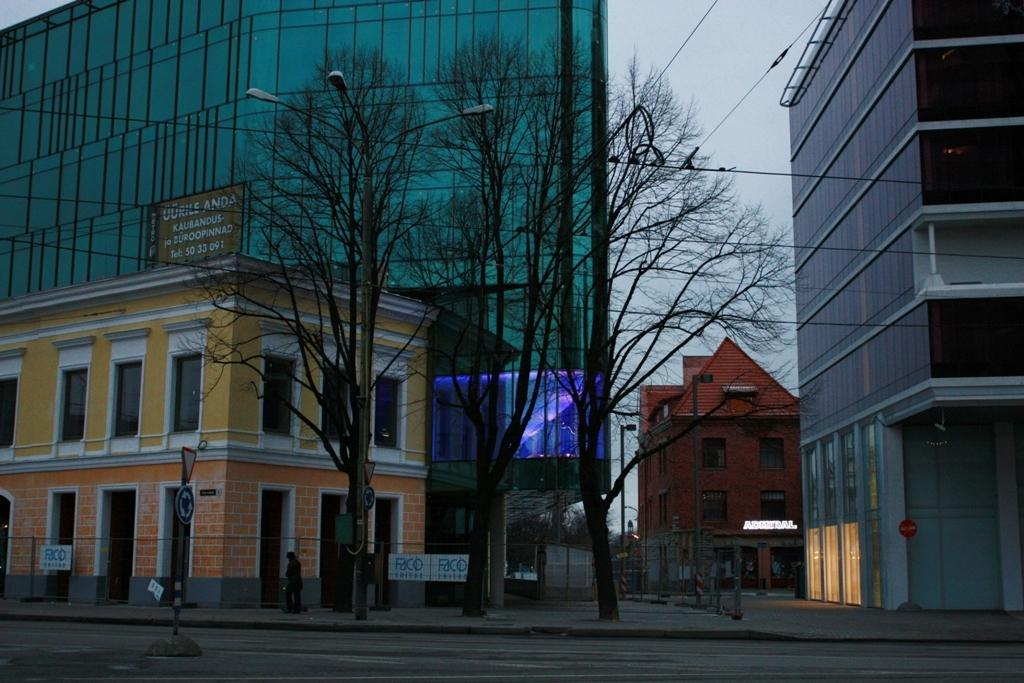What can be seen in the middle of the image? There are poles and sign boards in the middle of the image. What else is present in the image besides poles and sign boards? There are trees and buildings in the image. What is visible behind the buildings in the image? The sky is visible behind the buildings. What type of soup is being served in the image? There is no soup present in the image. What scent can be detected in the image? There is no mention of any scent in the image. 